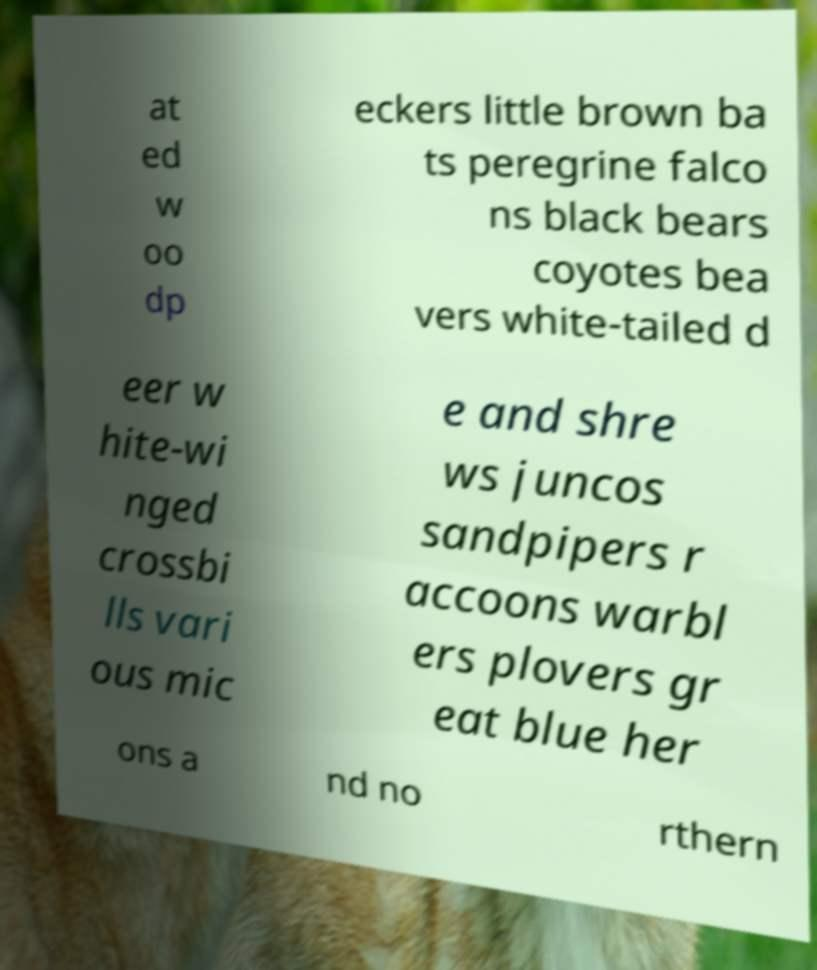There's text embedded in this image that I need extracted. Can you transcribe it verbatim? at ed w oo dp eckers little brown ba ts peregrine falco ns black bears coyotes bea vers white-tailed d eer w hite-wi nged crossbi lls vari ous mic e and shre ws juncos sandpipers r accoons warbl ers plovers gr eat blue her ons a nd no rthern 